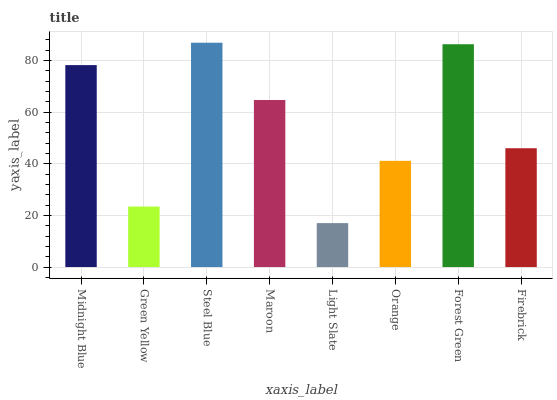Is Green Yellow the minimum?
Answer yes or no. No. Is Green Yellow the maximum?
Answer yes or no. No. Is Midnight Blue greater than Green Yellow?
Answer yes or no. Yes. Is Green Yellow less than Midnight Blue?
Answer yes or no. Yes. Is Green Yellow greater than Midnight Blue?
Answer yes or no. No. Is Midnight Blue less than Green Yellow?
Answer yes or no. No. Is Maroon the high median?
Answer yes or no. Yes. Is Firebrick the low median?
Answer yes or no. Yes. Is Steel Blue the high median?
Answer yes or no. No. Is Light Slate the low median?
Answer yes or no. No. 